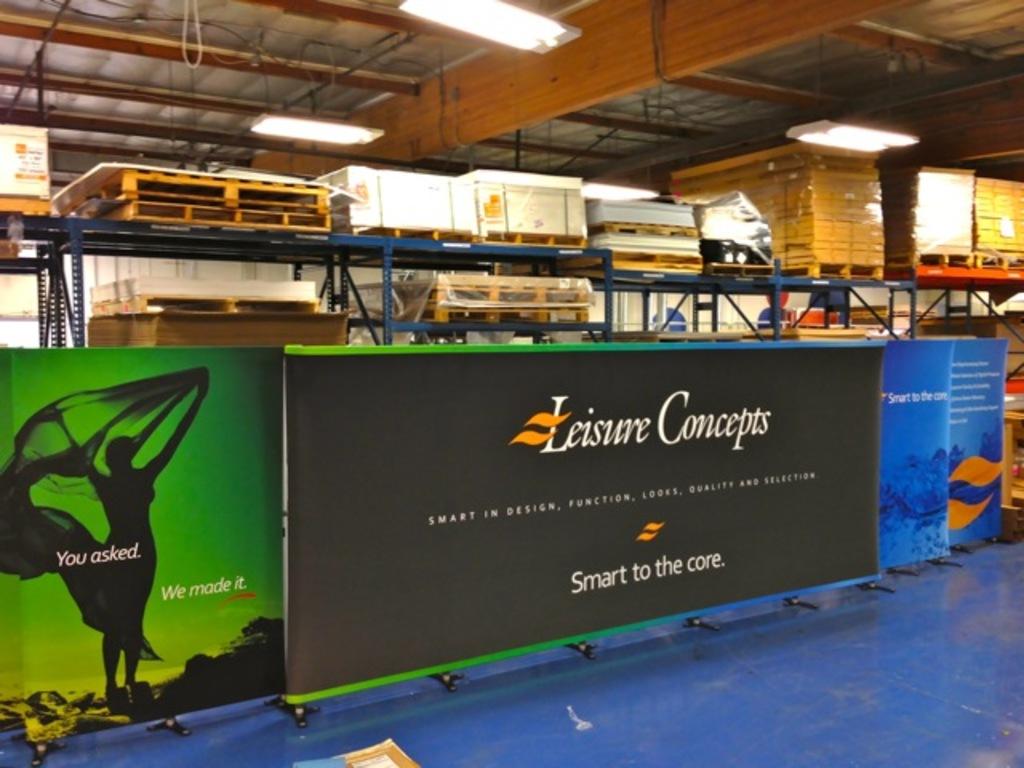What slogan is written on the bottom of the leisure concepts sign?
Your answer should be compact. Smart to the core. 